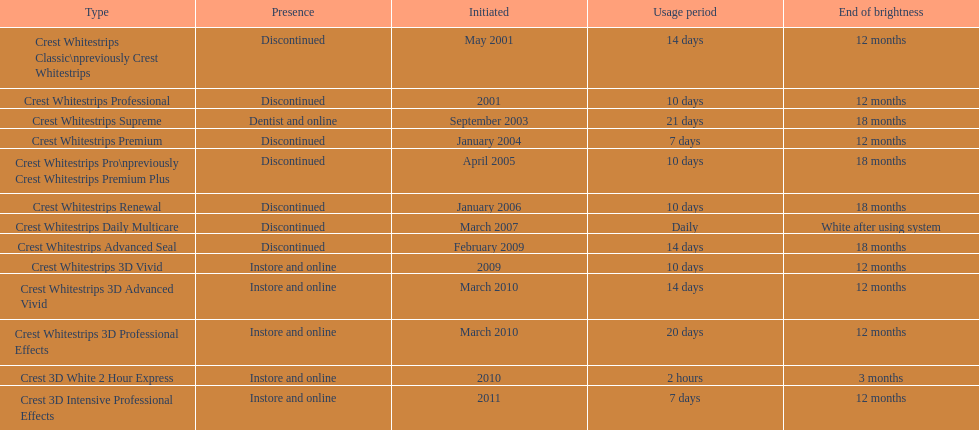Which product was to be used longer, crest whitestrips classic or crest whitestrips 3d vivid? Crest Whitestrips Classic. 